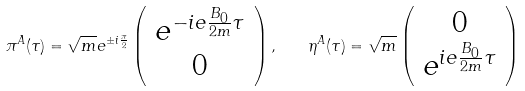<formula> <loc_0><loc_0><loc_500><loc_500>\pi ^ { A } ( \tau ) = \sqrt { m } e ^ { \pm i \frac { \pi } { 2 } } \left ( \begin{array} { c } e ^ { - i e \frac { B _ { 0 } } { 2 m } \tau } \\ 0 \\ \end{array} \right ) , \quad \eta ^ { A } ( \tau ) = \sqrt { m } \left ( \begin{array} { c } 0 \\ e ^ { i e \frac { B _ { 0 } } { 2 m } \tau } \\ \end{array} \right )</formula> 